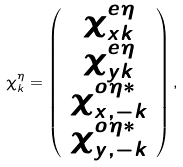Convert formula to latex. <formula><loc_0><loc_0><loc_500><loc_500>\chi ^ { \eta } _ { k } = \left ( \begin{array} { c } \chi ^ { e \eta } _ { x k } \\ \chi ^ { e \eta } _ { y k } \\ \chi ^ { o \eta * } _ { x , - k } \\ \chi ^ { o \eta * } _ { y , - k } \end{array} \right ) ,</formula> 